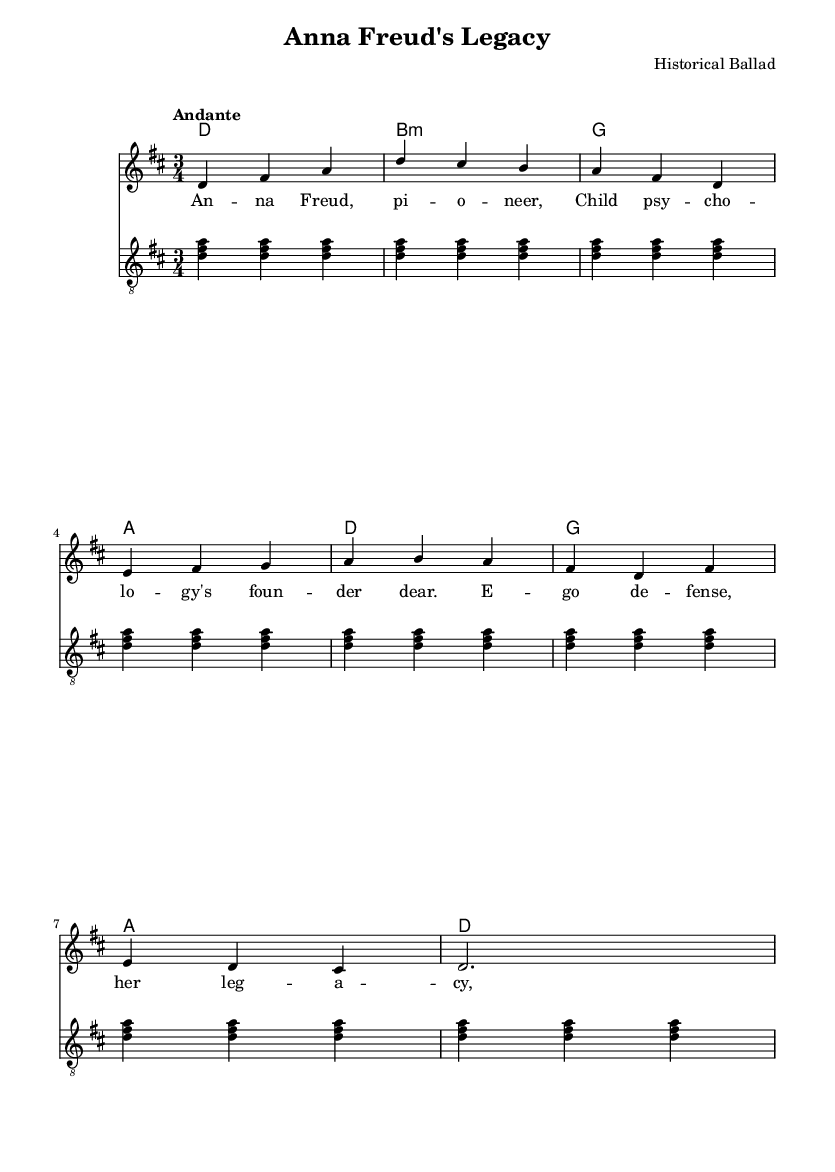What is the key signature of this music? The key signature indicated is D major, which has two sharps (F# and C#). This is confirmed by looking at the clef and the placement of sharps at the beginning of the staff.
Answer: D major What is the time signature? The time signature shown in this sheet music is 3/4, which is evidenced by the numerical indication at the beginning of the score. It signifies that there are three beats per measure and the quarter note gets one beat.
Answer: 3/4 What is the tempo marking of this piece? The tempo of this piece is marked as "Andante." This marking conveys a moderate walking pace, which helps to inform the performer how to interpret the speed of the music.
Answer: Andante How many measures are present in the melody? The melody consists of a total of 8 measures, which can be counted by looking at the grouping of the notes separated by vertical lines (bar lines). Each section between bar lines represents one measure.
Answer: 8 What unique thematic element is represented in the lyrics? The lyrics focus on Anna Freud and her contributions to child psychology. This thematic element highlights the achievements of a significant woman in psychology, emphasizing her legacy.
Answer: Anna Freud What harmony is used in the first measure? The first measure of harmony uses the chord D major, which is indicated by the presence of the root note D and its corresponding harmonic structure. This is crucial for setting the foundational tone of the piece.
Answer: D Which instrument has a treble clef in this score? The guitar section uses a treble clef, as shown at the beginning of its staff. The treble clef signifies that this instrument plays notes in the higher pitch range.
Answer: Guitar 